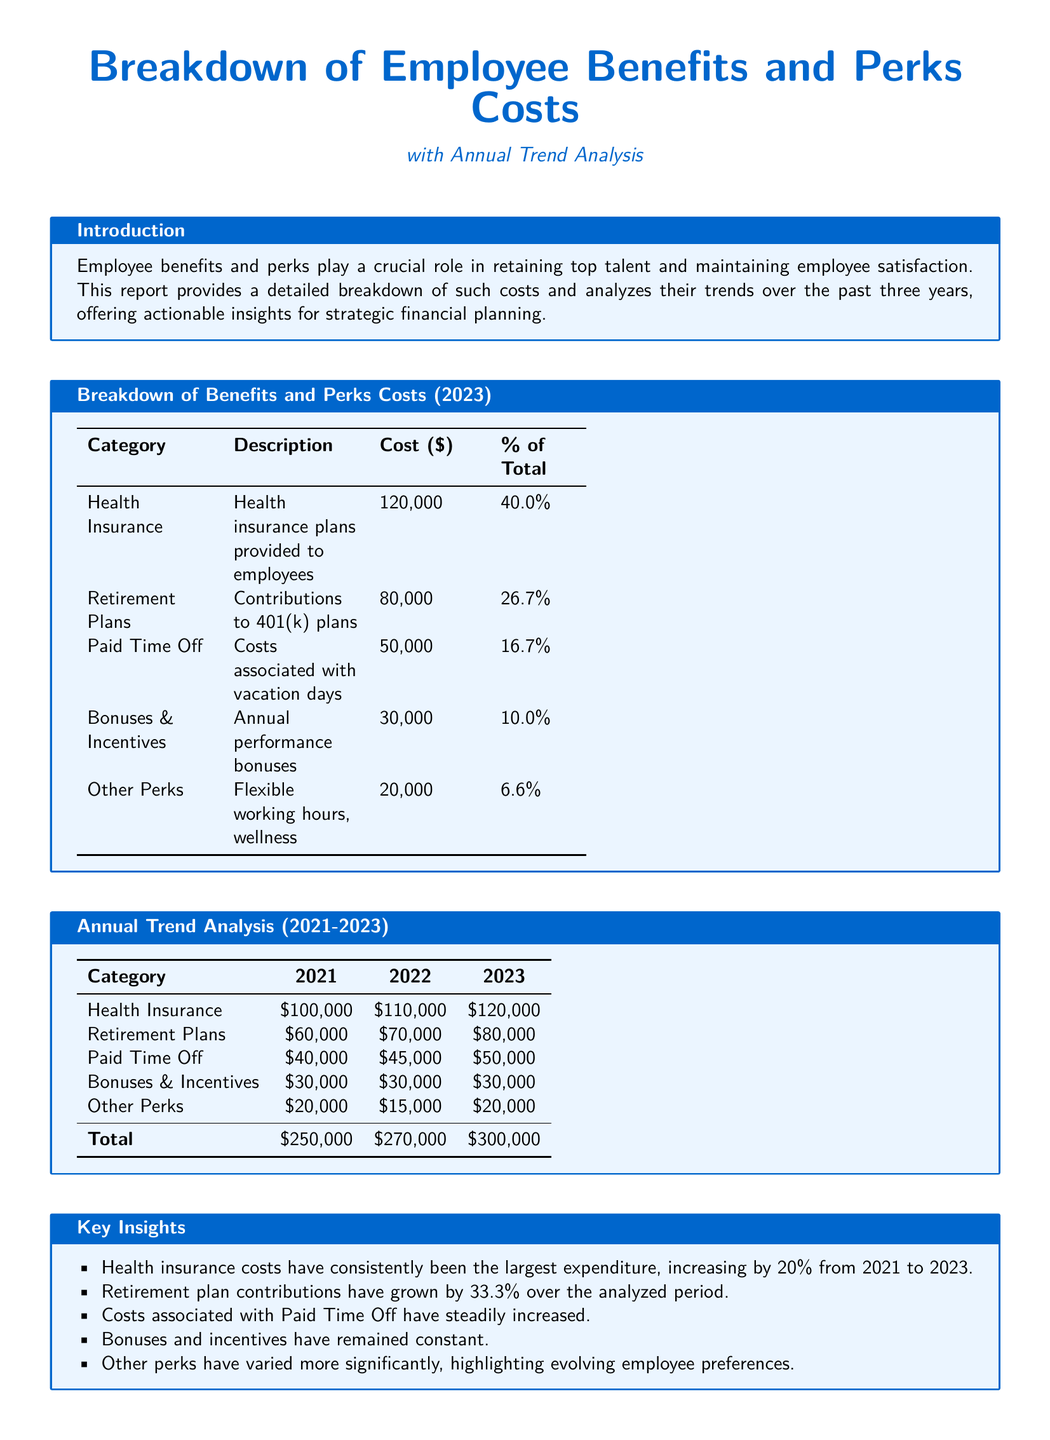What is the total cost of employee benefits in 2023? The total cost is presented in the breakdown section of the document, which states the total as $300,000.
Answer: $300,000 Which category has the highest percentage of total costs? The document indicates that Health Insurance accounts for 40.0% of total costs, the highest percentage among all categories.
Answer: Health Insurance By how much did Retirement Plans increase from 2021 to 2023? The difference in cost from 2021 ($60,000) to 2023 ($80,000) indicates an increase of $20,000, which represents a 33.3% growth.
Answer: $20,000 What was the cost of Other Perks in 2022? The annual trend analysis section specifically shows that Other Perks cost $15,000 in 2022.
Answer: $15,000 What is the trend for Paid Time Off costs over the three years? The document states that Paid Time Off costs have steadily increased each year: $40,000 in 2021, $45,000 in 2022, and $50,000 in 2023.
Answer: Steadily increased What is the description for the Bonuses & Incentives category? The description for this category in the benefits breakdown specifies that it involves "Annual performance bonuses."
Answer: Annual performance bonuses What total amount did health insurance costs increase between 2021 and 2023? The increase can be calculated from the cost in 2021 ($100,000) to 2023 ($120,000), which means an increase of $20,000.
Answer: $20,000 How has the cost of Other Perks changed from 2021 to 2023? The costs for Other Perks decreased from $20,000 in 2021 to $20,000 in 2023, but varied by reaching $15,000 in 2022.
Answer: Varied 